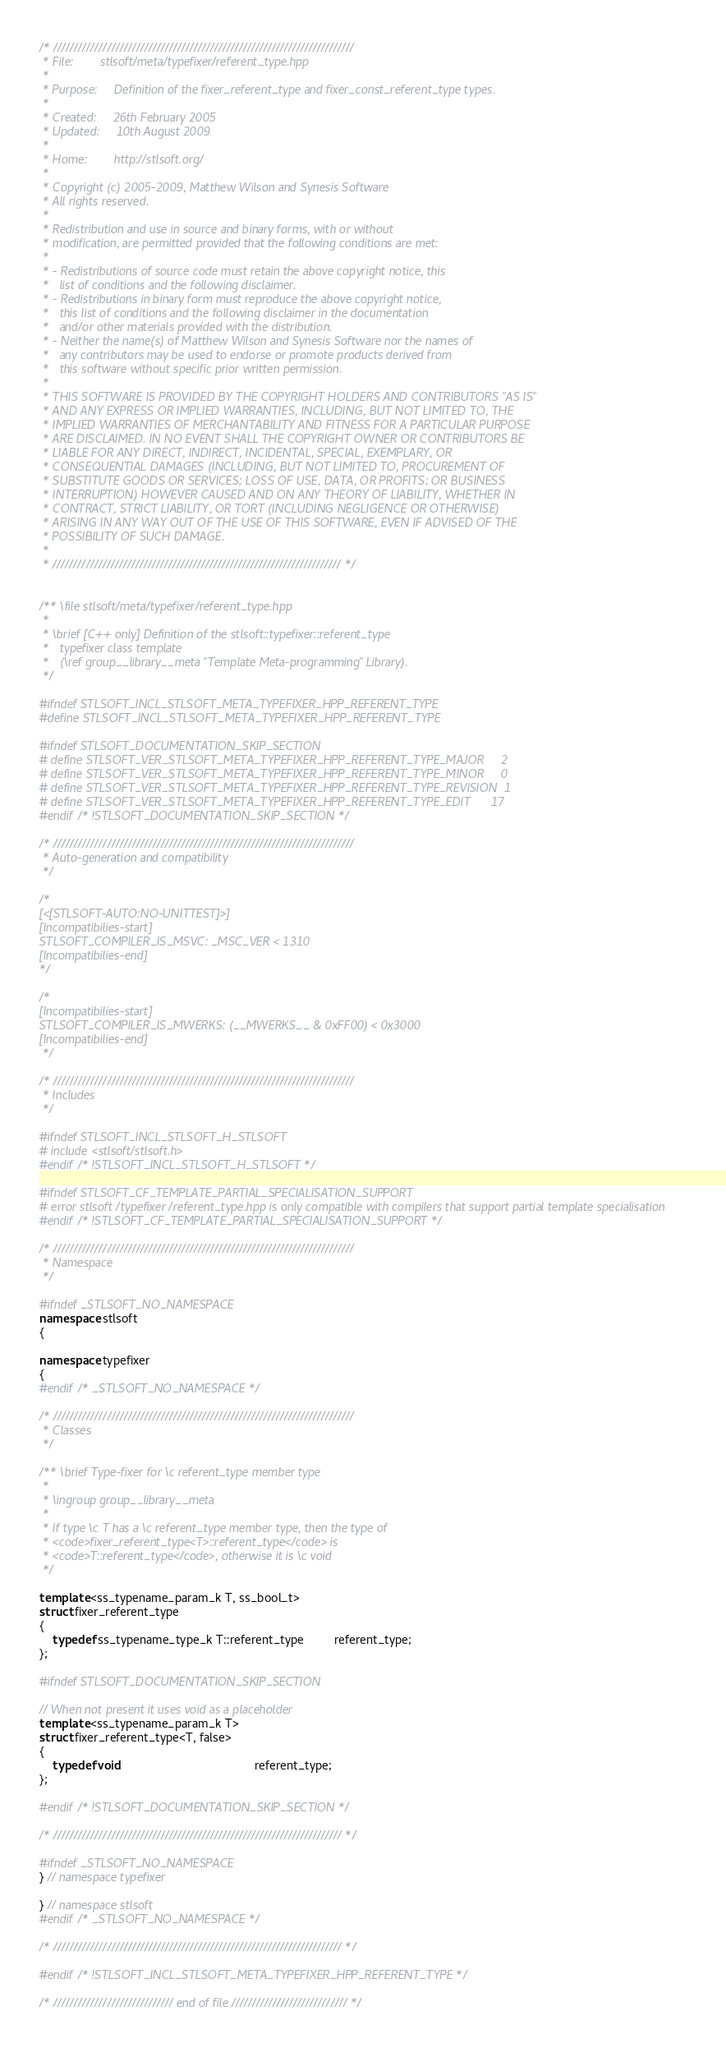<code> <loc_0><loc_0><loc_500><loc_500><_C++_>/* /////////////////////////////////////////////////////////////////////////
 * File:        stlsoft/meta/typefixer/referent_type.hpp
 *
 * Purpose:     Definition of the fixer_referent_type and fixer_const_referent_type types.
 *
 * Created:     26th February 2005
 * Updated:     10th August 2009
 *
 * Home:        http://stlsoft.org/
 *
 * Copyright (c) 2005-2009, Matthew Wilson and Synesis Software
 * All rights reserved.
 *
 * Redistribution and use in source and binary forms, with or without
 * modification, are permitted provided that the following conditions are met:
 *
 * - Redistributions of source code must retain the above copyright notice, this
 *   list of conditions and the following disclaimer.
 * - Redistributions in binary form must reproduce the above copyright notice,
 *   this list of conditions and the following disclaimer in the documentation
 *   and/or other materials provided with the distribution.
 * - Neither the name(s) of Matthew Wilson and Synesis Software nor the names of
 *   any contributors may be used to endorse or promote products derived from
 *   this software without specific prior written permission.
 *
 * THIS SOFTWARE IS PROVIDED BY THE COPYRIGHT HOLDERS AND CONTRIBUTORS "AS IS"
 * AND ANY EXPRESS OR IMPLIED WARRANTIES, INCLUDING, BUT NOT LIMITED TO, THE
 * IMPLIED WARRANTIES OF MERCHANTABILITY AND FITNESS FOR A PARTICULAR PURPOSE
 * ARE DISCLAIMED. IN NO EVENT SHALL THE COPYRIGHT OWNER OR CONTRIBUTORS BE
 * LIABLE FOR ANY DIRECT, INDIRECT, INCIDENTAL, SPECIAL, EXEMPLARY, OR
 * CONSEQUENTIAL DAMAGES (INCLUDING, BUT NOT LIMITED TO, PROCUREMENT OF
 * SUBSTITUTE GOODS OR SERVICES; LOSS OF USE, DATA, OR PROFITS; OR BUSINESS
 * INTERRUPTION) HOWEVER CAUSED AND ON ANY THEORY OF LIABILITY, WHETHER IN
 * CONTRACT, STRICT LIABILITY, OR TORT (INCLUDING NEGLIGENCE OR OTHERWISE)
 * ARISING IN ANY WAY OUT OF THE USE OF THIS SOFTWARE, EVEN IF ADVISED OF THE
 * POSSIBILITY OF SUCH DAMAGE.
 *
 * ////////////////////////////////////////////////////////////////////// */


/** \file stlsoft/meta/typefixer/referent_type.hpp
 *
 * \brief [C++ only] Definition of the stlsoft::typefixer::referent_type
 *   typefixer class template
 *   (\ref group__library__meta "Template Meta-programming" Library).
 */

#ifndef STLSOFT_INCL_STLSOFT_META_TYPEFIXER_HPP_REFERENT_TYPE
#define STLSOFT_INCL_STLSOFT_META_TYPEFIXER_HPP_REFERENT_TYPE

#ifndef STLSOFT_DOCUMENTATION_SKIP_SECTION
# define STLSOFT_VER_STLSOFT_META_TYPEFIXER_HPP_REFERENT_TYPE_MAJOR     2
# define STLSOFT_VER_STLSOFT_META_TYPEFIXER_HPP_REFERENT_TYPE_MINOR     0
# define STLSOFT_VER_STLSOFT_META_TYPEFIXER_HPP_REFERENT_TYPE_REVISION  1
# define STLSOFT_VER_STLSOFT_META_TYPEFIXER_HPP_REFERENT_TYPE_EDIT      17
#endif /* !STLSOFT_DOCUMENTATION_SKIP_SECTION */

/* /////////////////////////////////////////////////////////////////////////
 * Auto-generation and compatibility
 */

/*
[<[STLSOFT-AUTO:NO-UNITTEST]>]
[Incompatibilies-start]
STLSOFT_COMPILER_IS_MSVC: _MSC_VER < 1310
[Incompatibilies-end]
*/

/*
[Incompatibilies-start]
STLSOFT_COMPILER_IS_MWERKS: (__MWERKS__ & 0xFF00) < 0x3000
[Incompatibilies-end]
 */

/* /////////////////////////////////////////////////////////////////////////
 * Includes
 */

#ifndef STLSOFT_INCL_STLSOFT_H_STLSOFT
# include <stlsoft/stlsoft.h>
#endif /* !STLSOFT_INCL_STLSOFT_H_STLSOFT */

#ifndef STLSOFT_CF_TEMPLATE_PARTIAL_SPECIALISATION_SUPPORT
# error stlsoft/typefixer/referent_type.hpp is only compatible with compilers that support partial template specialisation
#endif /* !STLSOFT_CF_TEMPLATE_PARTIAL_SPECIALISATION_SUPPORT */

/* /////////////////////////////////////////////////////////////////////////
 * Namespace
 */

#ifndef _STLSOFT_NO_NAMESPACE
namespace stlsoft
{

namespace typefixer
{
#endif /* _STLSOFT_NO_NAMESPACE */

/* /////////////////////////////////////////////////////////////////////////
 * Classes
 */

/** \brief Type-fixer for \c referent_type member type
 *
 * \ingroup group__library__meta
 *
 * If type \c T has a \c referent_type member type, then the type of
 * <code>fixer_referent_type<T>::referent_type</code> is
 * <code>T::referent_type</code>, otherwise it is \c void
 */

template <ss_typename_param_k T, ss_bool_t>
struct fixer_referent_type
{
    typedef ss_typename_type_k T::referent_type         referent_type;
};

#ifndef STLSOFT_DOCUMENTATION_SKIP_SECTION

// When not present it uses void as a placeholder
template <ss_typename_param_k T>
struct fixer_referent_type<T, false>
{
    typedef void                                        referent_type;
};

#endif /* !STLSOFT_DOCUMENTATION_SKIP_SECTION */

/* ////////////////////////////////////////////////////////////////////// */

#ifndef _STLSOFT_NO_NAMESPACE
} // namespace typefixer

} // namespace stlsoft
#endif /* _STLSOFT_NO_NAMESPACE */

/* ////////////////////////////////////////////////////////////////////// */

#endif /* !STLSOFT_INCL_STLSOFT_META_TYPEFIXER_HPP_REFERENT_TYPE */

/* ///////////////////////////// end of file //////////////////////////// */
</code> 